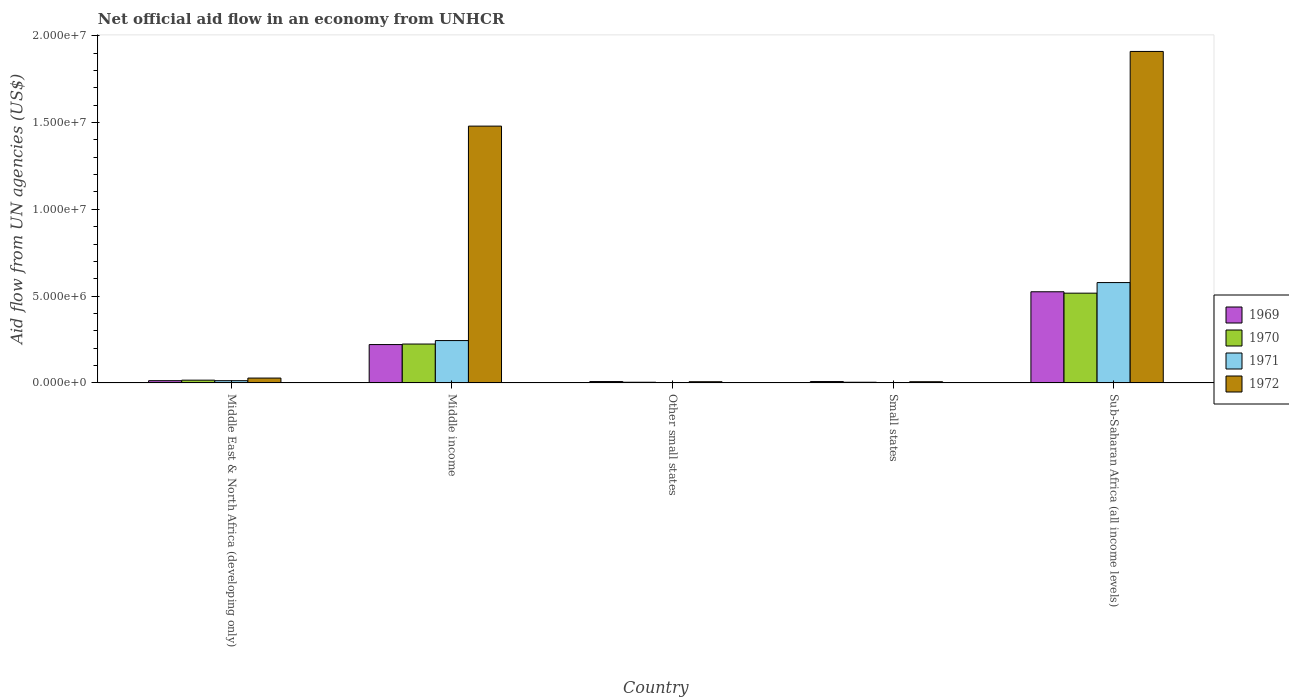How many different coloured bars are there?
Make the answer very short. 4. How many groups of bars are there?
Keep it short and to the point. 5. Are the number of bars per tick equal to the number of legend labels?
Give a very brief answer. Yes. Are the number of bars on each tick of the X-axis equal?
Your response must be concise. Yes. How many bars are there on the 2nd tick from the right?
Make the answer very short. 4. What is the label of the 5th group of bars from the left?
Make the answer very short. Sub-Saharan Africa (all income levels). Across all countries, what is the maximum net official aid flow in 1969?
Provide a succinct answer. 5.25e+06. In which country was the net official aid flow in 1970 maximum?
Offer a terse response. Sub-Saharan Africa (all income levels). In which country was the net official aid flow in 1972 minimum?
Your answer should be very brief. Other small states. What is the total net official aid flow in 1969 in the graph?
Your response must be concise. 7.75e+06. What is the difference between the net official aid flow in 1970 in Middle income and that in Other small states?
Make the answer very short. 2.20e+06. What is the difference between the net official aid flow in 1970 in Middle East & North Africa (developing only) and the net official aid flow in 1972 in Sub-Saharan Africa (all income levels)?
Give a very brief answer. -1.89e+07. What is the average net official aid flow in 1972 per country?
Ensure brevity in your answer.  6.86e+06. What is the difference between the net official aid flow of/in 1969 and net official aid flow of/in 1971 in Sub-Saharan Africa (all income levels)?
Give a very brief answer. -5.30e+05. What is the ratio of the net official aid flow in 1969 in Middle income to that in Sub-Saharan Africa (all income levels)?
Make the answer very short. 0.42. Is the net official aid flow in 1969 in Middle East & North Africa (developing only) less than that in Other small states?
Provide a succinct answer. No. What is the difference between the highest and the second highest net official aid flow in 1970?
Give a very brief answer. 2.93e+06. What is the difference between the highest and the lowest net official aid flow in 1970?
Keep it short and to the point. 5.13e+06. In how many countries, is the net official aid flow in 1971 greater than the average net official aid flow in 1971 taken over all countries?
Offer a terse response. 2. Is it the case that in every country, the sum of the net official aid flow in 1969 and net official aid flow in 1972 is greater than the sum of net official aid flow in 1971 and net official aid flow in 1970?
Offer a terse response. No. What does the 2nd bar from the right in Small states represents?
Your answer should be compact. 1971. Is it the case that in every country, the sum of the net official aid flow in 1972 and net official aid flow in 1970 is greater than the net official aid flow in 1969?
Offer a terse response. Yes. Are all the bars in the graph horizontal?
Offer a very short reply. No. Are the values on the major ticks of Y-axis written in scientific E-notation?
Offer a terse response. Yes. Does the graph contain any zero values?
Ensure brevity in your answer.  No. Where does the legend appear in the graph?
Your answer should be compact. Center right. What is the title of the graph?
Keep it short and to the point. Net official aid flow in an economy from UNHCR. What is the label or title of the X-axis?
Provide a succinct answer. Country. What is the label or title of the Y-axis?
Provide a short and direct response. Aid flow from UN agencies (US$). What is the Aid flow from UN agencies (US$) in 1969 in Middle East & North Africa (developing only)?
Your answer should be compact. 1.30e+05. What is the Aid flow from UN agencies (US$) of 1970 in Middle East & North Africa (developing only)?
Offer a terse response. 1.60e+05. What is the Aid flow from UN agencies (US$) of 1972 in Middle East & North Africa (developing only)?
Offer a very short reply. 2.80e+05. What is the Aid flow from UN agencies (US$) in 1969 in Middle income?
Offer a very short reply. 2.21e+06. What is the Aid flow from UN agencies (US$) in 1970 in Middle income?
Your answer should be very brief. 2.24e+06. What is the Aid flow from UN agencies (US$) of 1971 in Middle income?
Ensure brevity in your answer.  2.44e+06. What is the Aid flow from UN agencies (US$) of 1972 in Middle income?
Offer a very short reply. 1.48e+07. What is the Aid flow from UN agencies (US$) in 1972 in Small states?
Your response must be concise. 7.00e+04. What is the Aid flow from UN agencies (US$) in 1969 in Sub-Saharan Africa (all income levels)?
Your response must be concise. 5.25e+06. What is the Aid flow from UN agencies (US$) of 1970 in Sub-Saharan Africa (all income levels)?
Make the answer very short. 5.17e+06. What is the Aid flow from UN agencies (US$) of 1971 in Sub-Saharan Africa (all income levels)?
Offer a very short reply. 5.78e+06. What is the Aid flow from UN agencies (US$) in 1972 in Sub-Saharan Africa (all income levels)?
Ensure brevity in your answer.  1.91e+07. Across all countries, what is the maximum Aid flow from UN agencies (US$) of 1969?
Your answer should be compact. 5.25e+06. Across all countries, what is the maximum Aid flow from UN agencies (US$) of 1970?
Provide a short and direct response. 5.17e+06. Across all countries, what is the maximum Aid flow from UN agencies (US$) of 1971?
Your answer should be very brief. 5.78e+06. Across all countries, what is the maximum Aid flow from UN agencies (US$) in 1972?
Your response must be concise. 1.91e+07. What is the total Aid flow from UN agencies (US$) in 1969 in the graph?
Give a very brief answer. 7.75e+06. What is the total Aid flow from UN agencies (US$) in 1970 in the graph?
Your answer should be compact. 7.65e+06. What is the total Aid flow from UN agencies (US$) in 1971 in the graph?
Provide a succinct answer. 8.39e+06. What is the total Aid flow from UN agencies (US$) in 1972 in the graph?
Your response must be concise. 3.43e+07. What is the difference between the Aid flow from UN agencies (US$) in 1969 in Middle East & North Africa (developing only) and that in Middle income?
Offer a very short reply. -2.08e+06. What is the difference between the Aid flow from UN agencies (US$) in 1970 in Middle East & North Africa (developing only) and that in Middle income?
Provide a short and direct response. -2.08e+06. What is the difference between the Aid flow from UN agencies (US$) of 1971 in Middle East & North Africa (developing only) and that in Middle income?
Your answer should be very brief. -2.31e+06. What is the difference between the Aid flow from UN agencies (US$) of 1972 in Middle East & North Africa (developing only) and that in Middle income?
Ensure brevity in your answer.  -1.45e+07. What is the difference between the Aid flow from UN agencies (US$) of 1972 in Middle East & North Africa (developing only) and that in Other small states?
Provide a short and direct response. 2.10e+05. What is the difference between the Aid flow from UN agencies (US$) of 1969 in Middle East & North Africa (developing only) and that in Small states?
Ensure brevity in your answer.  5.00e+04. What is the difference between the Aid flow from UN agencies (US$) of 1971 in Middle East & North Africa (developing only) and that in Small states?
Provide a short and direct response. 1.10e+05. What is the difference between the Aid flow from UN agencies (US$) in 1972 in Middle East & North Africa (developing only) and that in Small states?
Give a very brief answer. 2.10e+05. What is the difference between the Aid flow from UN agencies (US$) in 1969 in Middle East & North Africa (developing only) and that in Sub-Saharan Africa (all income levels)?
Provide a short and direct response. -5.12e+06. What is the difference between the Aid flow from UN agencies (US$) of 1970 in Middle East & North Africa (developing only) and that in Sub-Saharan Africa (all income levels)?
Offer a terse response. -5.01e+06. What is the difference between the Aid flow from UN agencies (US$) of 1971 in Middle East & North Africa (developing only) and that in Sub-Saharan Africa (all income levels)?
Ensure brevity in your answer.  -5.65e+06. What is the difference between the Aid flow from UN agencies (US$) in 1972 in Middle East & North Africa (developing only) and that in Sub-Saharan Africa (all income levels)?
Ensure brevity in your answer.  -1.88e+07. What is the difference between the Aid flow from UN agencies (US$) of 1969 in Middle income and that in Other small states?
Make the answer very short. 2.13e+06. What is the difference between the Aid flow from UN agencies (US$) of 1970 in Middle income and that in Other small states?
Provide a succinct answer. 2.20e+06. What is the difference between the Aid flow from UN agencies (US$) of 1971 in Middle income and that in Other small states?
Your answer should be very brief. 2.42e+06. What is the difference between the Aid flow from UN agencies (US$) of 1972 in Middle income and that in Other small states?
Your answer should be very brief. 1.47e+07. What is the difference between the Aid flow from UN agencies (US$) of 1969 in Middle income and that in Small states?
Ensure brevity in your answer.  2.13e+06. What is the difference between the Aid flow from UN agencies (US$) of 1970 in Middle income and that in Small states?
Keep it short and to the point. 2.20e+06. What is the difference between the Aid flow from UN agencies (US$) in 1971 in Middle income and that in Small states?
Provide a short and direct response. 2.42e+06. What is the difference between the Aid flow from UN agencies (US$) of 1972 in Middle income and that in Small states?
Make the answer very short. 1.47e+07. What is the difference between the Aid flow from UN agencies (US$) in 1969 in Middle income and that in Sub-Saharan Africa (all income levels)?
Provide a succinct answer. -3.04e+06. What is the difference between the Aid flow from UN agencies (US$) in 1970 in Middle income and that in Sub-Saharan Africa (all income levels)?
Your response must be concise. -2.93e+06. What is the difference between the Aid flow from UN agencies (US$) of 1971 in Middle income and that in Sub-Saharan Africa (all income levels)?
Ensure brevity in your answer.  -3.34e+06. What is the difference between the Aid flow from UN agencies (US$) in 1972 in Middle income and that in Sub-Saharan Africa (all income levels)?
Give a very brief answer. -4.30e+06. What is the difference between the Aid flow from UN agencies (US$) of 1970 in Other small states and that in Small states?
Give a very brief answer. 0. What is the difference between the Aid flow from UN agencies (US$) of 1969 in Other small states and that in Sub-Saharan Africa (all income levels)?
Provide a succinct answer. -5.17e+06. What is the difference between the Aid flow from UN agencies (US$) in 1970 in Other small states and that in Sub-Saharan Africa (all income levels)?
Offer a very short reply. -5.13e+06. What is the difference between the Aid flow from UN agencies (US$) in 1971 in Other small states and that in Sub-Saharan Africa (all income levels)?
Keep it short and to the point. -5.76e+06. What is the difference between the Aid flow from UN agencies (US$) in 1972 in Other small states and that in Sub-Saharan Africa (all income levels)?
Your answer should be compact. -1.90e+07. What is the difference between the Aid flow from UN agencies (US$) of 1969 in Small states and that in Sub-Saharan Africa (all income levels)?
Give a very brief answer. -5.17e+06. What is the difference between the Aid flow from UN agencies (US$) of 1970 in Small states and that in Sub-Saharan Africa (all income levels)?
Your answer should be very brief. -5.13e+06. What is the difference between the Aid flow from UN agencies (US$) in 1971 in Small states and that in Sub-Saharan Africa (all income levels)?
Provide a succinct answer. -5.76e+06. What is the difference between the Aid flow from UN agencies (US$) in 1972 in Small states and that in Sub-Saharan Africa (all income levels)?
Keep it short and to the point. -1.90e+07. What is the difference between the Aid flow from UN agencies (US$) in 1969 in Middle East & North Africa (developing only) and the Aid flow from UN agencies (US$) in 1970 in Middle income?
Provide a succinct answer. -2.11e+06. What is the difference between the Aid flow from UN agencies (US$) in 1969 in Middle East & North Africa (developing only) and the Aid flow from UN agencies (US$) in 1971 in Middle income?
Ensure brevity in your answer.  -2.31e+06. What is the difference between the Aid flow from UN agencies (US$) of 1969 in Middle East & North Africa (developing only) and the Aid flow from UN agencies (US$) of 1972 in Middle income?
Ensure brevity in your answer.  -1.47e+07. What is the difference between the Aid flow from UN agencies (US$) of 1970 in Middle East & North Africa (developing only) and the Aid flow from UN agencies (US$) of 1971 in Middle income?
Keep it short and to the point. -2.28e+06. What is the difference between the Aid flow from UN agencies (US$) in 1970 in Middle East & North Africa (developing only) and the Aid flow from UN agencies (US$) in 1972 in Middle income?
Provide a short and direct response. -1.46e+07. What is the difference between the Aid flow from UN agencies (US$) in 1971 in Middle East & North Africa (developing only) and the Aid flow from UN agencies (US$) in 1972 in Middle income?
Provide a short and direct response. -1.47e+07. What is the difference between the Aid flow from UN agencies (US$) of 1969 in Middle East & North Africa (developing only) and the Aid flow from UN agencies (US$) of 1970 in Other small states?
Offer a terse response. 9.00e+04. What is the difference between the Aid flow from UN agencies (US$) of 1969 in Middle East & North Africa (developing only) and the Aid flow from UN agencies (US$) of 1972 in Other small states?
Provide a short and direct response. 6.00e+04. What is the difference between the Aid flow from UN agencies (US$) in 1970 in Middle East & North Africa (developing only) and the Aid flow from UN agencies (US$) in 1971 in Other small states?
Ensure brevity in your answer.  1.40e+05. What is the difference between the Aid flow from UN agencies (US$) in 1970 in Middle East & North Africa (developing only) and the Aid flow from UN agencies (US$) in 1972 in Other small states?
Your response must be concise. 9.00e+04. What is the difference between the Aid flow from UN agencies (US$) in 1971 in Middle East & North Africa (developing only) and the Aid flow from UN agencies (US$) in 1972 in Other small states?
Make the answer very short. 6.00e+04. What is the difference between the Aid flow from UN agencies (US$) in 1969 in Middle East & North Africa (developing only) and the Aid flow from UN agencies (US$) in 1971 in Small states?
Keep it short and to the point. 1.10e+05. What is the difference between the Aid flow from UN agencies (US$) of 1969 in Middle East & North Africa (developing only) and the Aid flow from UN agencies (US$) of 1972 in Small states?
Provide a succinct answer. 6.00e+04. What is the difference between the Aid flow from UN agencies (US$) of 1970 in Middle East & North Africa (developing only) and the Aid flow from UN agencies (US$) of 1972 in Small states?
Offer a terse response. 9.00e+04. What is the difference between the Aid flow from UN agencies (US$) in 1969 in Middle East & North Africa (developing only) and the Aid flow from UN agencies (US$) in 1970 in Sub-Saharan Africa (all income levels)?
Give a very brief answer. -5.04e+06. What is the difference between the Aid flow from UN agencies (US$) in 1969 in Middle East & North Africa (developing only) and the Aid flow from UN agencies (US$) in 1971 in Sub-Saharan Africa (all income levels)?
Your answer should be compact. -5.65e+06. What is the difference between the Aid flow from UN agencies (US$) in 1969 in Middle East & North Africa (developing only) and the Aid flow from UN agencies (US$) in 1972 in Sub-Saharan Africa (all income levels)?
Your answer should be very brief. -1.90e+07. What is the difference between the Aid flow from UN agencies (US$) in 1970 in Middle East & North Africa (developing only) and the Aid flow from UN agencies (US$) in 1971 in Sub-Saharan Africa (all income levels)?
Make the answer very short. -5.62e+06. What is the difference between the Aid flow from UN agencies (US$) in 1970 in Middle East & North Africa (developing only) and the Aid flow from UN agencies (US$) in 1972 in Sub-Saharan Africa (all income levels)?
Offer a very short reply. -1.89e+07. What is the difference between the Aid flow from UN agencies (US$) of 1971 in Middle East & North Africa (developing only) and the Aid flow from UN agencies (US$) of 1972 in Sub-Saharan Africa (all income levels)?
Provide a succinct answer. -1.90e+07. What is the difference between the Aid flow from UN agencies (US$) of 1969 in Middle income and the Aid flow from UN agencies (US$) of 1970 in Other small states?
Make the answer very short. 2.17e+06. What is the difference between the Aid flow from UN agencies (US$) of 1969 in Middle income and the Aid flow from UN agencies (US$) of 1971 in Other small states?
Make the answer very short. 2.19e+06. What is the difference between the Aid flow from UN agencies (US$) of 1969 in Middle income and the Aid flow from UN agencies (US$) of 1972 in Other small states?
Offer a terse response. 2.14e+06. What is the difference between the Aid flow from UN agencies (US$) of 1970 in Middle income and the Aid flow from UN agencies (US$) of 1971 in Other small states?
Make the answer very short. 2.22e+06. What is the difference between the Aid flow from UN agencies (US$) of 1970 in Middle income and the Aid flow from UN agencies (US$) of 1972 in Other small states?
Your answer should be compact. 2.17e+06. What is the difference between the Aid flow from UN agencies (US$) in 1971 in Middle income and the Aid flow from UN agencies (US$) in 1972 in Other small states?
Ensure brevity in your answer.  2.37e+06. What is the difference between the Aid flow from UN agencies (US$) of 1969 in Middle income and the Aid flow from UN agencies (US$) of 1970 in Small states?
Ensure brevity in your answer.  2.17e+06. What is the difference between the Aid flow from UN agencies (US$) in 1969 in Middle income and the Aid flow from UN agencies (US$) in 1971 in Small states?
Provide a succinct answer. 2.19e+06. What is the difference between the Aid flow from UN agencies (US$) of 1969 in Middle income and the Aid flow from UN agencies (US$) of 1972 in Small states?
Offer a very short reply. 2.14e+06. What is the difference between the Aid flow from UN agencies (US$) of 1970 in Middle income and the Aid flow from UN agencies (US$) of 1971 in Small states?
Make the answer very short. 2.22e+06. What is the difference between the Aid flow from UN agencies (US$) in 1970 in Middle income and the Aid flow from UN agencies (US$) in 1972 in Small states?
Your answer should be very brief. 2.17e+06. What is the difference between the Aid flow from UN agencies (US$) of 1971 in Middle income and the Aid flow from UN agencies (US$) of 1972 in Small states?
Ensure brevity in your answer.  2.37e+06. What is the difference between the Aid flow from UN agencies (US$) of 1969 in Middle income and the Aid flow from UN agencies (US$) of 1970 in Sub-Saharan Africa (all income levels)?
Make the answer very short. -2.96e+06. What is the difference between the Aid flow from UN agencies (US$) in 1969 in Middle income and the Aid flow from UN agencies (US$) in 1971 in Sub-Saharan Africa (all income levels)?
Your answer should be compact. -3.57e+06. What is the difference between the Aid flow from UN agencies (US$) in 1969 in Middle income and the Aid flow from UN agencies (US$) in 1972 in Sub-Saharan Africa (all income levels)?
Make the answer very short. -1.69e+07. What is the difference between the Aid flow from UN agencies (US$) in 1970 in Middle income and the Aid flow from UN agencies (US$) in 1971 in Sub-Saharan Africa (all income levels)?
Offer a very short reply. -3.54e+06. What is the difference between the Aid flow from UN agencies (US$) of 1970 in Middle income and the Aid flow from UN agencies (US$) of 1972 in Sub-Saharan Africa (all income levels)?
Offer a very short reply. -1.68e+07. What is the difference between the Aid flow from UN agencies (US$) in 1971 in Middle income and the Aid flow from UN agencies (US$) in 1972 in Sub-Saharan Africa (all income levels)?
Offer a terse response. -1.66e+07. What is the difference between the Aid flow from UN agencies (US$) in 1969 in Other small states and the Aid flow from UN agencies (US$) in 1970 in Sub-Saharan Africa (all income levels)?
Your response must be concise. -5.09e+06. What is the difference between the Aid flow from UN agencies (US$) of 1969 in Other small states and the Aid flow from UN agencies (US$) of 1971 in Sub-Saharan Africa (all income levels)?
Make the answer very short. -5.70e+06. What is the difference between the Aid flow from UN agencies (US$) in 1969 in Other small states and the Aid flow from UN agencies (US$) in 1972 in Sub-Saharan Africa (all income levels)?
Provide a succinct answer. -1.90e+07. What is the difference between the Aid flow from UN agencies (US$) of 1970 in Other small states and the Aid flow from UN agencies (US$) of 1971 in Sub-Saharan Africa (all income levels)?
Your response must be concise. -5.74e+06. What is the difference between the Aid flow from UN agencies (US$) of 1970 in Other small states and the Aid flow from UN agencies (US$) of 1972 in Sub-Saharan Africa (all income levels)?
Ensure brevity in your answer.  -1.90e+07. What is the difference between the Aid flow from UN agencies (US$) of 1971 in Other small states and the Aid flow from UN agencies (US$) of 1972 in Sub-Saharan Africa (all income levels)?
Your response must be concise. -1.91e+07. What is the difference between the Aid flow from UN agencies (US$) of 1969 in Small states and the Aid flow from UN agencies (US$) of 1970 in Sub-Saharan Africa (all income levels)?
Ensure brevity in your answer.  -5.09e+06. What is the difference between the Aid flow from UN agencies (US$) of 1969 in Small states and the Aid flow from UN agencies (US$) of 1971 in Sub-Saharan Africa (all income levels)?
Keep it short and to the point. -5.70e+06. What is the difference between the Aid flow from UN agencies (US$) of 1969 in Small states and the Aid flow from UN agencies (US$) of 1972 in Sub-Saharan Africa (all income levels)?
Provide a succinct answer. -1.90e+07. What is the difference between the Aid flow from UN agencies (US$) in 1970 in Small states and the Aid flow from UN agencies (US$) in 1971 in Sub-Saharan Africa (all income levels)?
Ensure brevity in your answer.  -5.74e+06. What is the difference between the Aid flow from UN agencies (US$) of 1970 in Small states and the Aid flow from UN agencies (US$) of 1972 in Sub-Saharan Africa (all income levels)?
Your answer should be compact. -1.90e+07. What is the difference between the Aid flow from UN agencies (US$) in 1971 in Small states and the Aid flow from UN agencies (US$) in 1972 in Sub-Saharan Africa (all income levels)?
Your answer should be very brief. -1.91e+07. What is the average Aid flow from UN agencies (US$) in 1969 per country?
Provide a short and direct response. 1.55e+06. What is the average Aid flow from UN agencies (US$) of 1970 per country?
Provide a short and direct response. 1.53e+06. What is the average Aid flow from UN agencies (US$) in 1971 per country?
Your answer should be very brief. 1.68e+06. What is the average Aid flow from UN agencies (US$) of 1972 per country?
Ensure brevity in your answer.  6.86e+06. What is the difference between the Aid flow from UN agencies (US$) of 1969 and Aid flow from UN agencies (US$) of 1970 in Middle East & North Africa (developing only)?
Ensure brevity in your answer.  -3.00e+04. What is the difference between the Aid flow from UN agencies (US$) in 1969 and Aid flow from UN agencies (US$) in 1971 in Middle East & North Africa (developing only)?
Your answer should be compact. 0. What is the difference between the Aid flow from UN agencies (US$) in 1970 and Aid flow from UN agencies (US$) in 1972 in Middle East & North Africa (developing only)?
Give a very brief answer. -1.20e+05. What is the difference between the Aid flow from UN agencies (US$) in 1969 and Aid flow from UN agencies (US$) in 1972 in Middle income?
Offer a very short reply. -1.26e+07. What is the difference between the Aid flow from UN agencies (US$) of 1970 and Aid flow from UN agencies (US$) of 1972 in Middle income?
Your answer should be very brief. -1.26e+07. What is the difference between the Aid flow from UN agencies (US$) in 1971 and Aid flow from UN agencies (US$) in 1972 in Middle income?
Your response must be concise. -1.24e+07. What is the difference between the Aid flow from UN agencies (US$) of 1970 and Aid flow from UN agencies (US$) of 1972 in Other small states?
Your response must be concise. -3.00e+04. What is the difference between the Aid flow from UN agencies (US$) in 1971 and Aid flow from UN agencies (US$) in 1972 in Small states?
Keep it short and to the point. -5.00e+04. What is the difference between the Aid flow from UN agencies (US$) in 1969 and Aid flow from UN agencies (US$) in 1971 in Sub-Saharan Africa (all income levels)?
Your answer should be very brief. -5.30e+05. What is the difference between the Aid flow from UN agencies (US$) of 1969 and Aid flow from UN agencies (US$) of 1972 in Sub-Saharan Africa (all income levels)?
Provide a short and direct response. -1.38e+07. What is the difference between the Aid flow from UN agencies (US$) in 1970 and Aid flow from UN agencies (US$) in 1971 in Sub-Saharan Africa (all income levels)?
Give a very brief answer. -6.10e+05. What is the difference between the Aid flow from UN agencies (US$) of 1970 and Aid flow from UN agencies (US$) of 1972 in Sub-Saharan Africa (all income levels)?
Your answer should be compact. -1.39e+07. What is the difference between the Aid flow from UN agencies (US$) in 1971 and Aid flow from UN agencies (US$) in 1972 in Sub-Saharan Africa (all income levels)?
Offer a terse response. -1.33e+07. What is the ratio of the Aid flow from UN agencies (US$) of 1969 in Middle East & North Africa (developing only) to that in Middle income?
Keep it short and to the point. 0.06. What is the ratio of the Aid flow from UN agencies (US$) of 1970 in Middle East & North Africa (developing only) to that in Middle income?
Provide a short and direct response. 0.07. What is the ratio of the Aid flow from UN agencies (US$) of 1971 in Middle East & North Africa (developing only) to that in Middle income?
Provide a succinct answer. 0.05. What is the ratio of the Aid flow from UN agencies (US$) of 1972 in Middle East & North Africa (developing only) to that in Middle income?
Offer a terse response. 0.02. What is the ratio of the Aid flow from UN agencies (US$) of 1969 in Middle East & North Africa (developing only) to that in Other small states?
Keep it short and to the point. 1.62. What is the ratio of the Aid flow from UN agencies (US$) of 1970 in Middle East & North Africa (developing only) to that in Other small states?
Provide a succinct answer. 4. What is the ratio of the Aid flow from UN agencies (US$) in 1969 in Middle East & North Africa (developing only) to that in Small states?
Make the answer very short. 1.62. What is the ratio of the Aid flow from UN agencies (US$) of 1971 in Middle East & North Africa (developing only) to that in Small states?
Provide a short and direct response. 6.5. What is the ratio of the Aid flow from UN agencies (US$) of 1969 in Middle East & North Africa (developing only) to that in Sub-Saharan Africa (all income levels)?
Your response must be concise. 0.02. What is the ratio of the Aid flow from UN agencies (US$) of 1970 in Middle East & North Africa (developing only) to that in Sub-Saharan Africa (all income levels)?
Your answer should be very brief. 0.03. What is the ratio of the Aid flow from UN agencies (US$) in 1971 in Middle East & North Africa (developing only) to that in Sub-Saharan Africa (all income levels)?
Your answer should be compact. 0.02. What is the ratio of the Aid flow from UN agencies (US$) of 1972 in Middle East & North Africa (developing only) to that in Sub-Saharan Africa (all income levels)?
Offer a terse response. 0.01. What is the ratio of the Aid flow from UN agencies (US$) in 1969 in Middle income to that in Other small states?
Your answer should be very brief. 27.62. What is the ratio of the Aid flow from UN agencies (US$) of 1970 in Middle income to that in Other small states?
Give a very brief answer. 56. What is the ratio of the Aid flow from UN agencies (US$) of 1971 in Middle income to that in Other small states?
Offer a very short reply. 122. What is the ratio of the Aid flow from UN agencies (US$) of 1972 in Middle income to that in Other small states?
Ensure brevity in your answer.  211.29. What is the ratio of the Aid flow from UN agencies (US$) of 1969 in Middle income to that in Small states?
Provide a short and direct response. 27.62. What is the ratio of the Aid flow from UN agencies (US$) of 1970 in Middle income to that in Small states?
Your response must be concise. 56. What is the ratio of the Aid flow from UN agencies (US$) of 1971 in Middle income to that in Small states?
Ensure brevity in your answer.  122. What is the ratio of the Aid flow from UN agencies (US$) of 1972 in Middle income to that in Small states?
Give a very brief answer. 211.29. What is the ratio of the Aid flow from UN agencies (US$) in 1969 in Middle income to that in Sub-Saharan Africa (all income levels)?
Offer a very short reply. 0.42. What is the ratio of the Aid flow from UN agencies (US$) in 1970 in Middle income to that in Sub-Saharan Africa (all income levels)?
Your answer should be compact. 0.43. What is the ratio of the Aid flow from UN agencies (US$) in 1971 in Middle income to that in Sub-Saharan Africa (all income levels)?
Your answer should be very brief. 0.42. What is the ratio of the Aid flow from UN agencies (US$) in 1972 in Middle income to that in Sub-Saharan Africa (all income levels)?
Offer a very short reply. 0.77. What is the ratio of the Aid flow from UN agencies (US$) of 1970 in Other small states to that in Small states?
Your answer should be very brief. 1. What is the ratio of the Aid flow from UN agencies (US$) in 1971 in Other small states to that in Small states?
Offer a terse response. 1. What is the ratio of the Aid flow from UN agencies (US$) in 1972 in Other small states to that in Small states?
Give a very brief answer. 1. What is the ratio of the Aid flow from UN agencies (US$) in 1969 in Other small states to that in Sub-Saharan Africa (all income levels)?
Offer a terse response. 0.02. What is the ratio of the Aid flow from UN agencies (US$) in 1970 in Other small states to that in Sub-Saharan Africa (all income levels)?
Give a very brief answer. 0.01. What is the ratio of the Aid flow from UN agencies (US$) of 1971 in Other small states to that in Sub-Saharan Africa (all income levels)?
Provide a short and direct response. 0. What is the ratio of the Aid flow from UN agencies (US$) in 1972 in Other small states to that in Sub-Saharan Africa (all income levels)?
Offer a very short reply. 0. What is the ratio of the Aid flow from UN agencies (US$) of 1969 in Small states to that in Sub-Saharan Africa (all income levels)?
Provide a succinct answer. 0.02. What is the ratio of the Aid flow from UN agencies (US$) in 1970 in Small states to that in Sub-Saharan Africa (all income levels)?
Provide a succinct answer. 0.01. What is the ratio of the Aid flow from UN agencies (US$) in 1971 in Small states to that in Sub-Saharan Africa (all income levels)?
Provide a short and direct response. 0. What is the ratio of the Aid flow from UN agencies (US$) of 1972 in Small states to that in Sub-Saharan Africa (all income levels)?
Provide a succinct answer. 0. What is the difference between the highest and the second highest Aid flow from UN agencies (US$) in 1969?
Keep it short and to the point. 3.04e+06. What is the difference between the highest and the second highest Aid flow from UN agencies (US$) in 1970?
Offer a very short reply. 2.93e+06. What is the difference between the highest and the second highest Aid flow from UN agencies (US$) in 1971?
Your response must be concise. 3.34e+06. What is the difference between the highest and the second highest Aid flow from UN agencies (US$) of 1972?
Offer a very short reply. 4.30e+06. What is the difference between the highest and the lowest Aid flow from UN agencies (US$) in 1969?
Ensure brevity in your answer.  5.17e+06. What is the difference between the highest and the lowest Aid flow from UN agencies (US$) in 1970?
Make the answer very short. 5.13e+06. What is the difference between the highest and the lowest Aid flow from UN agencies (US$) in 1971?
Make the answer very short. 5.76e+06. What is the difference between the highest and the lowest Aid flow from UN agencies (US$) of 1972?
Your response must be concise. 1.90e+07. 